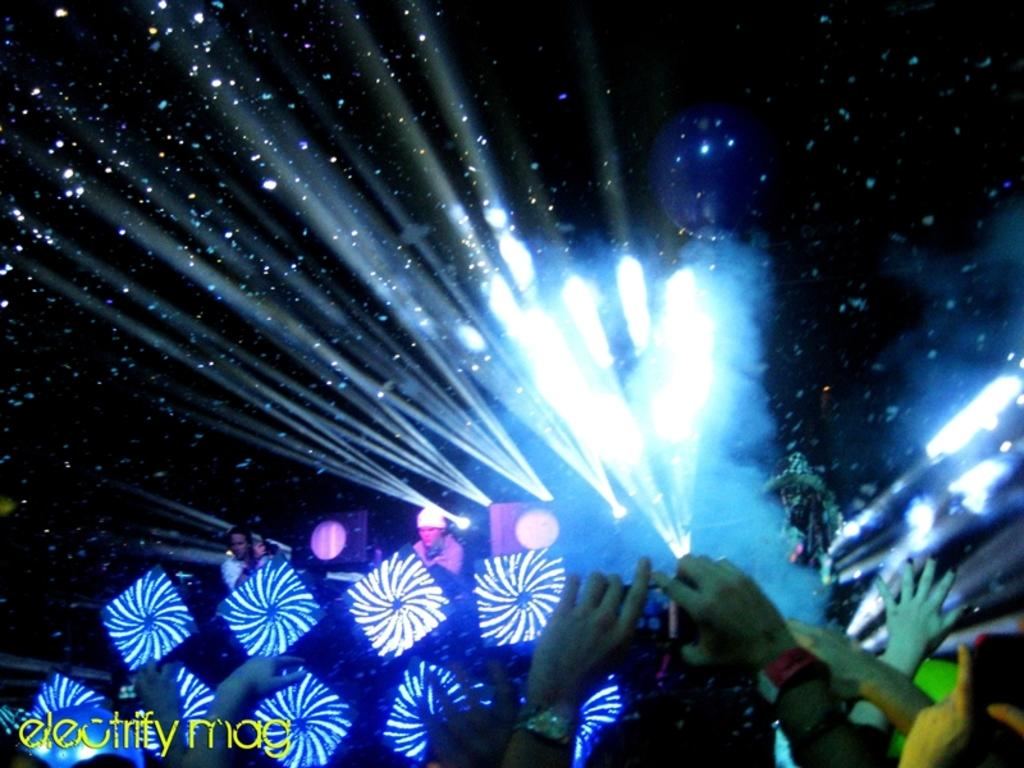How many people are in the image? There are multiple people in the image. What can be seen in the image besides the people? There are lights visible in the image. What are some people doing in the image? Some people are holding cameras. How would you describe the lighting in the image? The image appears to be slightly dark. Is there any additional information or branding present in the image? Yes, there is a watermark present in the image. How many pages are visible in the image? There are no pages present in the image; it is a photograph of people and lights. What type of frogs can be seen interacting with the people in the image? There are no frogs present in the image; it features people and lights. 